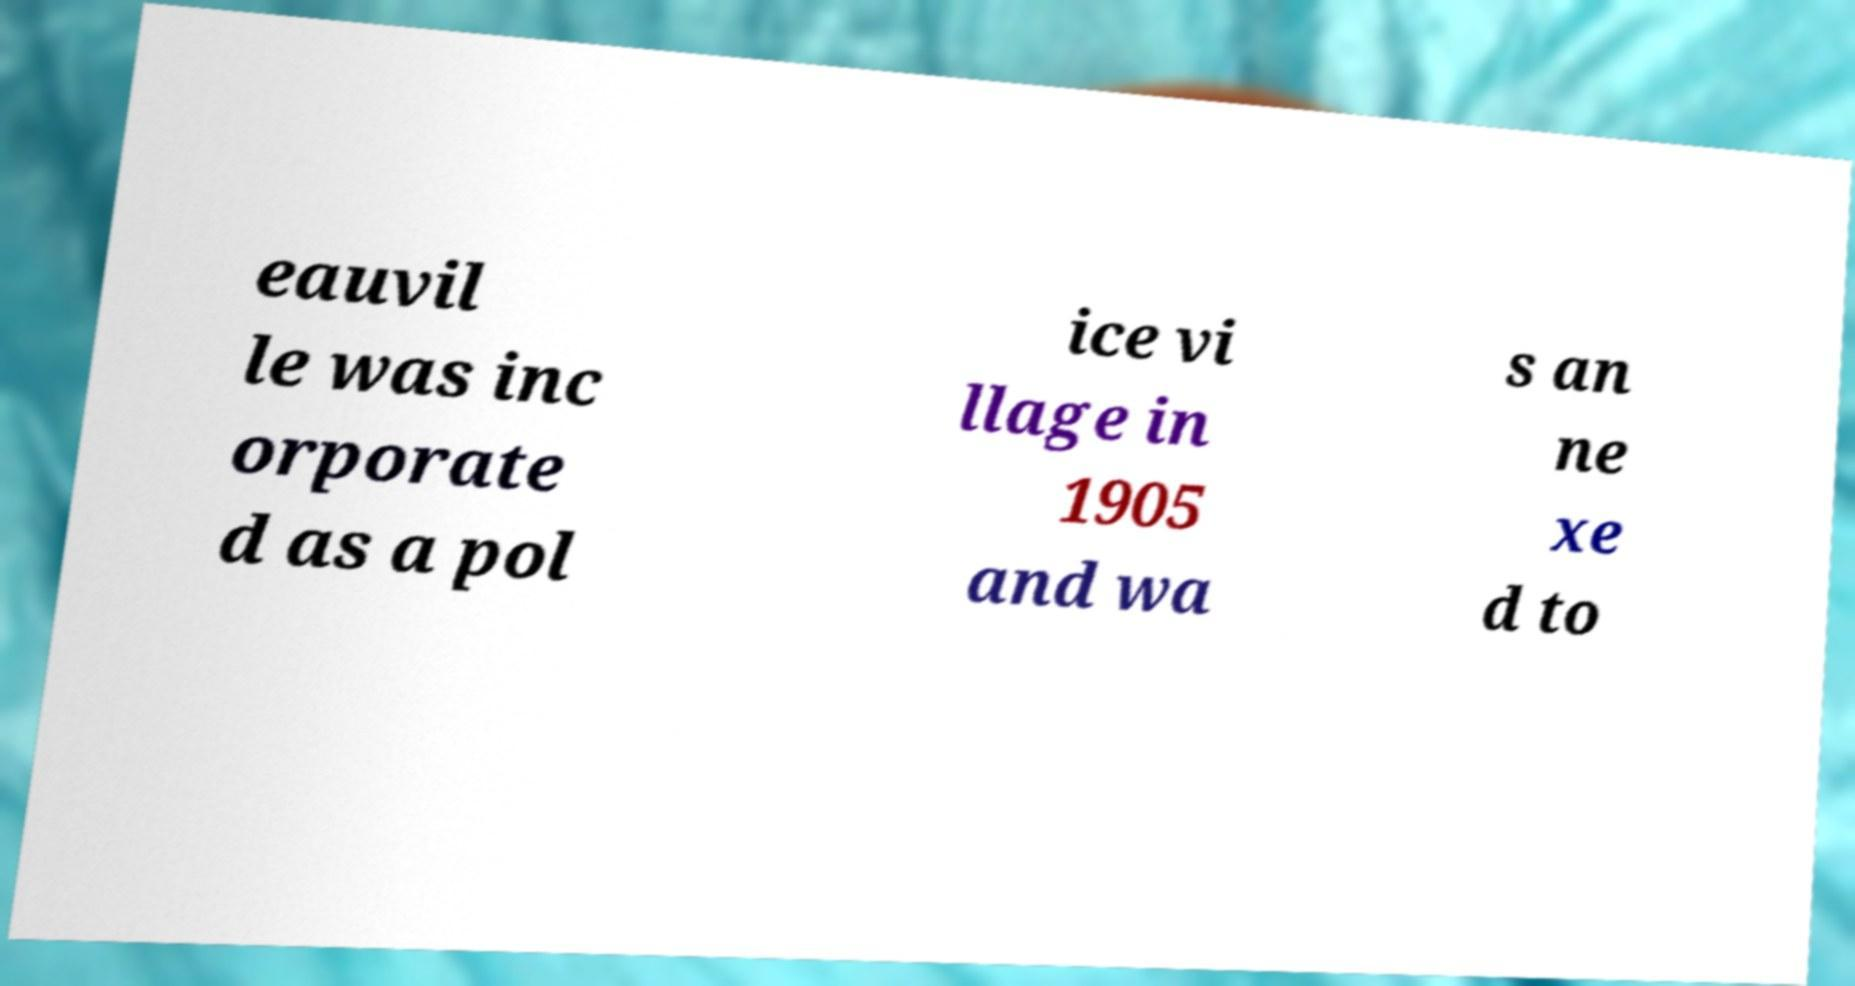What messages or text are displayed in this image? I need them in a readable, typed format. eauvil le was inc orporate d as a pol ice vi llage in 1905 and wa s an ne xe d to 